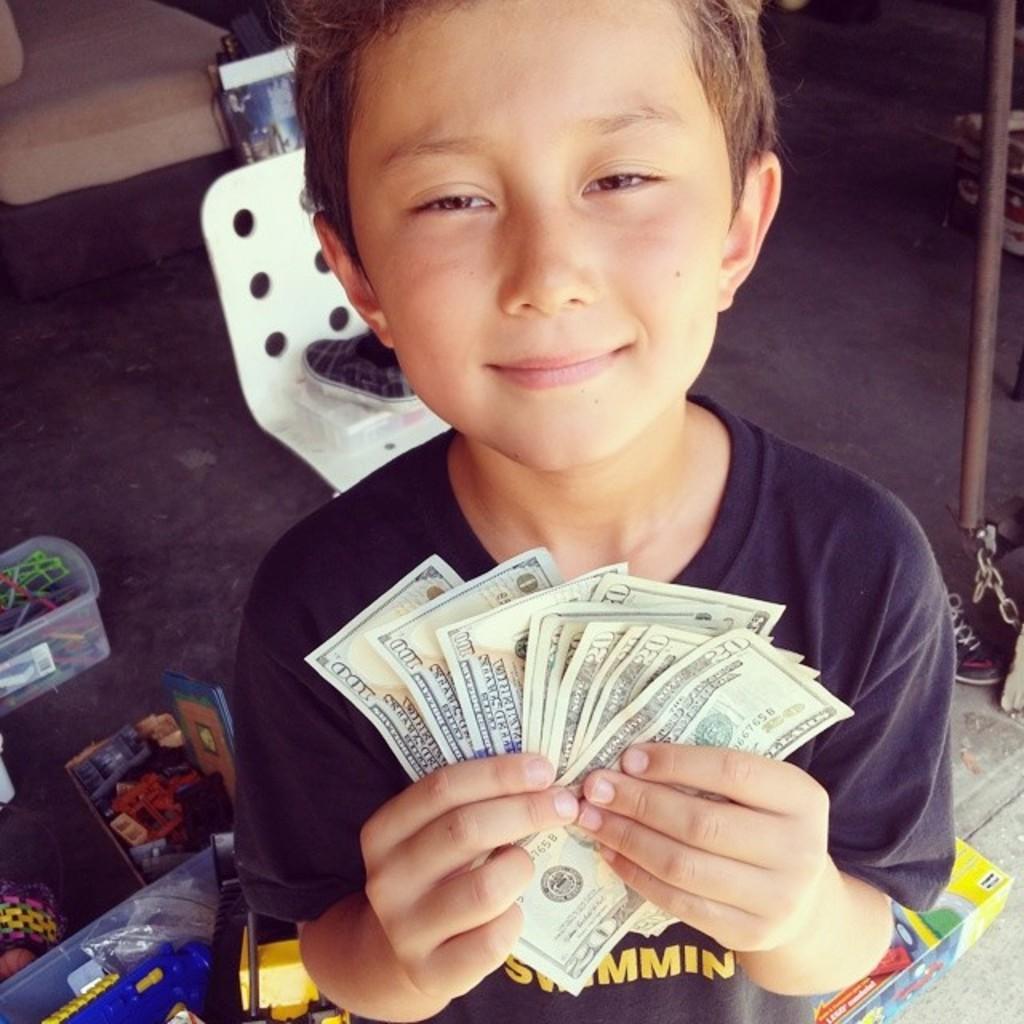Could you give a brief overview of what you see in this image? In this image there is a boy standing and holding the currency notes, and in the background there are toys and a chair on the carpet. 